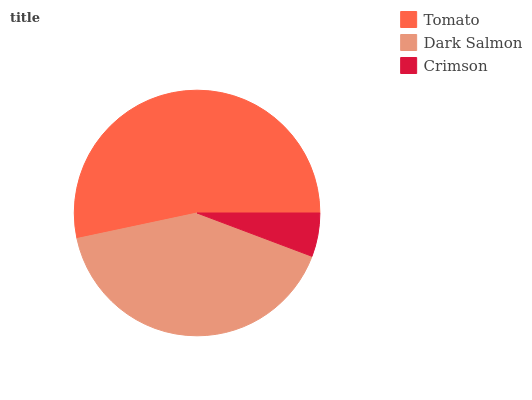Is Crimson the minimum?
Answer yes or no. Yes. Is Tomato the maximum?
Answer yes or no. Yes. Is Dark Salmon the minimum?
Answer yes or no. No. Is Dark Salmon the maximum?
Answer yes or no. No. Is Tomato greater than Dark Salmon?
Answer yes or no. Yes. Is Dark Salmon less than Tomato?
Answer yes or no. Yes. Is Dark Salmon greater than Tomato?
Answer yes or no. No. Is Tomato less than Dark Salmon?
Answer yes or no. No. Is Dark Salmon the high median?
Answer yes or no. Yes. Is Dark Salmon the low median?
Answer yes or no. Yes. Is Crimson the high median?
Answer yes or no. No. Is Crimson the low median?
Answer yes or no. No. 